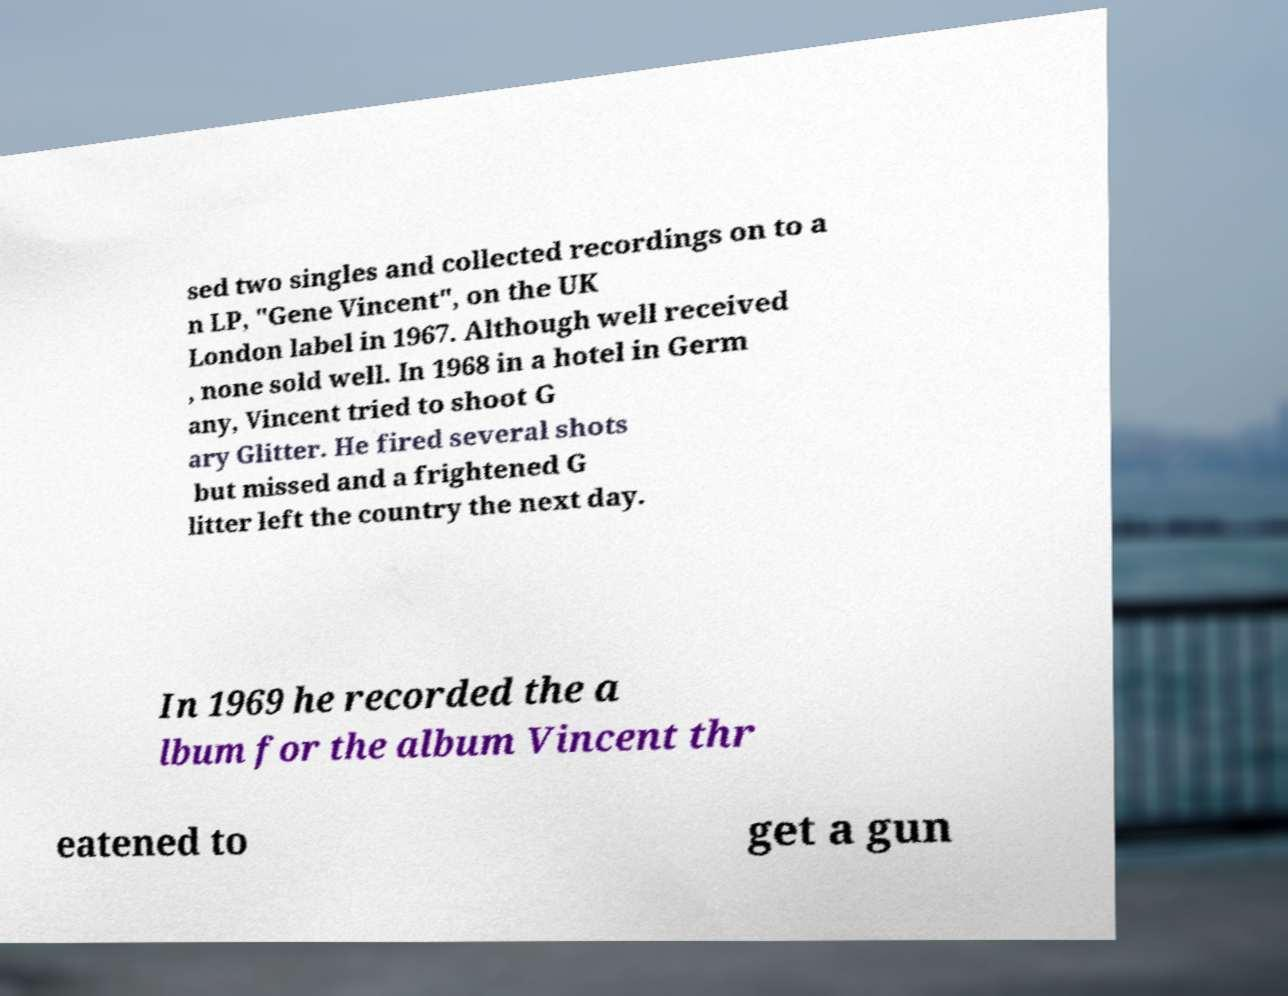What messages or text are displayed in this image? I need them in a readable, typed format. sed two singles and collected recordings on to a n LP, "Gene Vincent", on the UK London label in 1967. Although well received , none sold well. In 1968 in a hotel in Germ any, Vincent tried to shoot G ary Glitter. He fired several shots but missed and a frightened G litter left the country the next day. In 1969 he recorded the a lbum for the album Vincent thr eatened to get a gun 